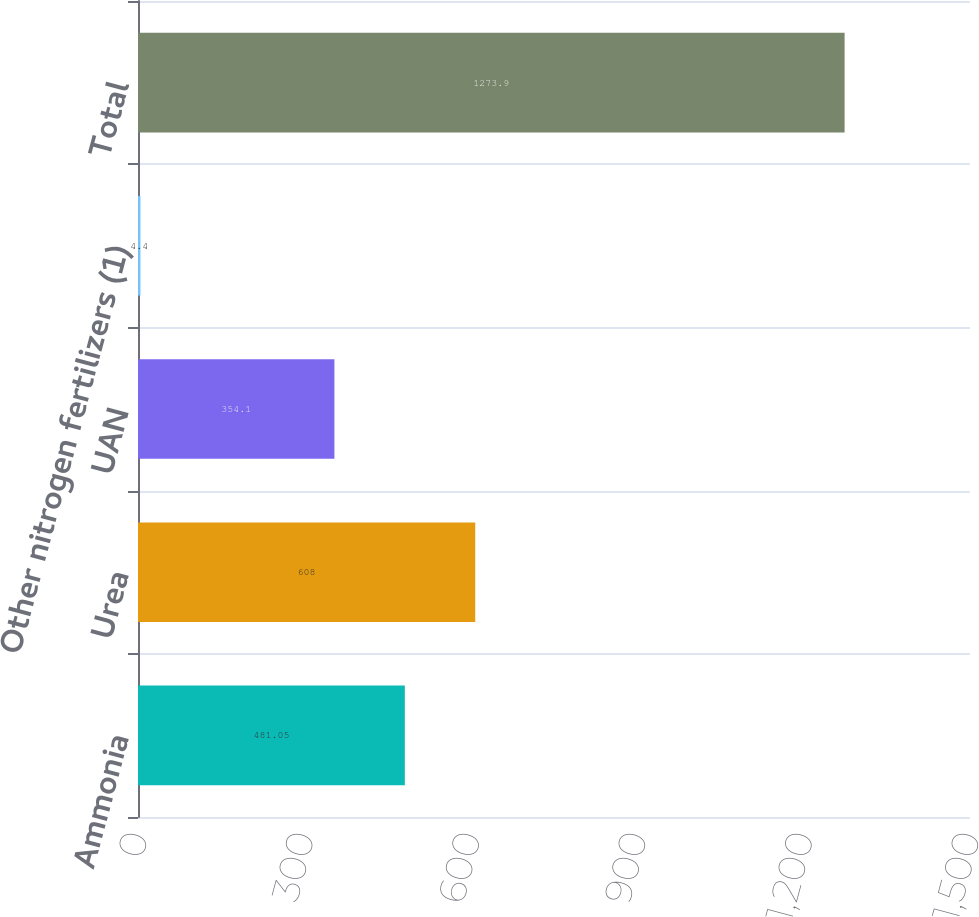Convert chart to OTSL. <chart><loc_0><loc_0><loc_500><loc_500><bar_chart><fcel>Ammonia<fcel>Urea<fcel>UAN<fcel>Other nitrogen fertilizers (1)<fcel>Total<nl><fcel>481.05<fcel>608<fcel>354.1<fcel>4.4<fcel>1273.9<nl></chart> 